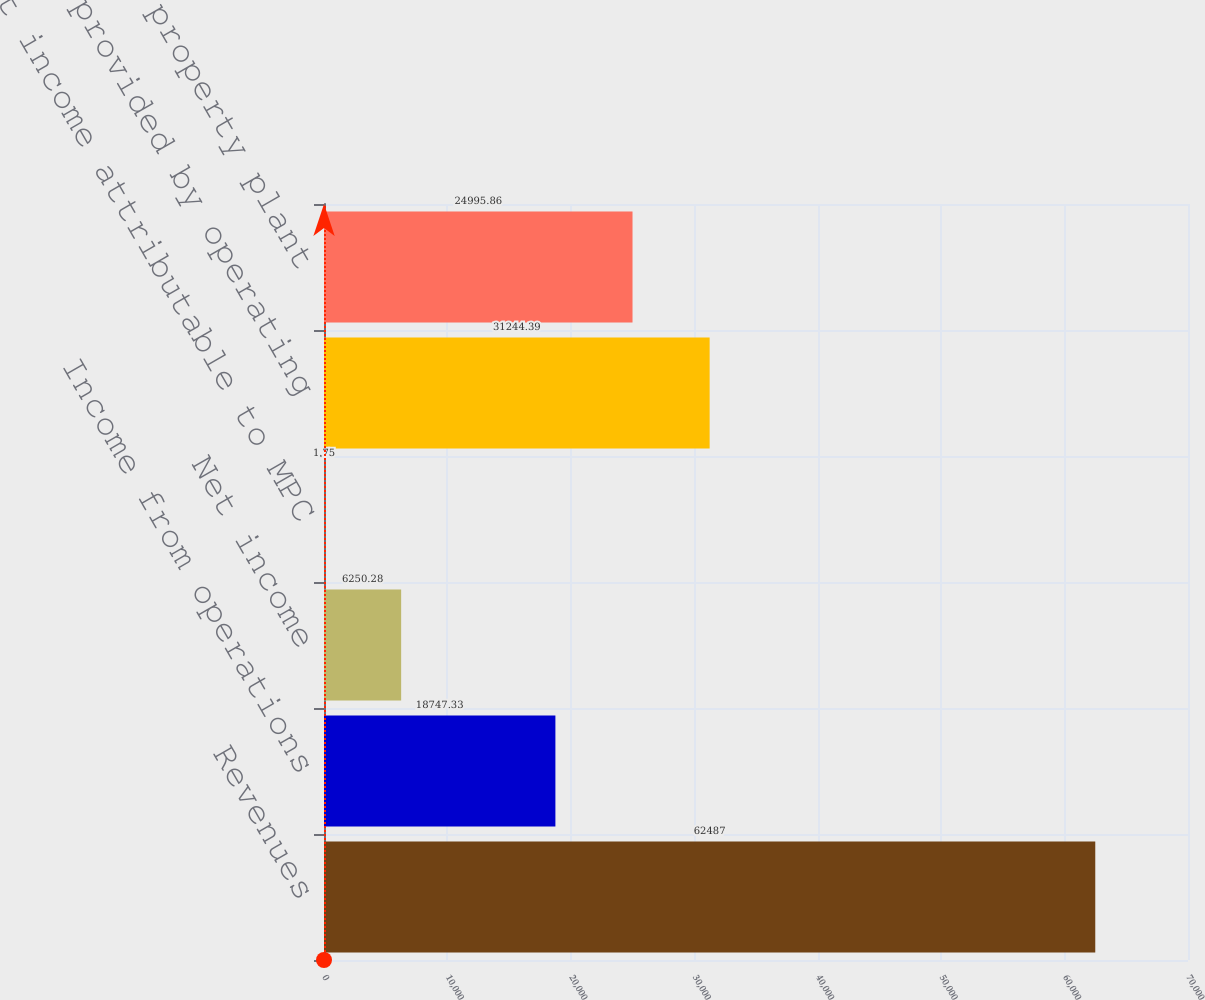Convert chart to OTSL. <chart><loc_0><loc_0><loc_500><loc_500><bar_chart><fcel>Revenues<fcel>Income from operations<fcel>Net income<fcel>Net income attributable to MPC<fcel>Net cash provided by operating<fcel>Additions to property plant<nl><fcel>62487<fcel>18747.3<fcel>6250.28<fcel>1.75<fcel>31244.4<fcel>24995.9<nl></chart> 